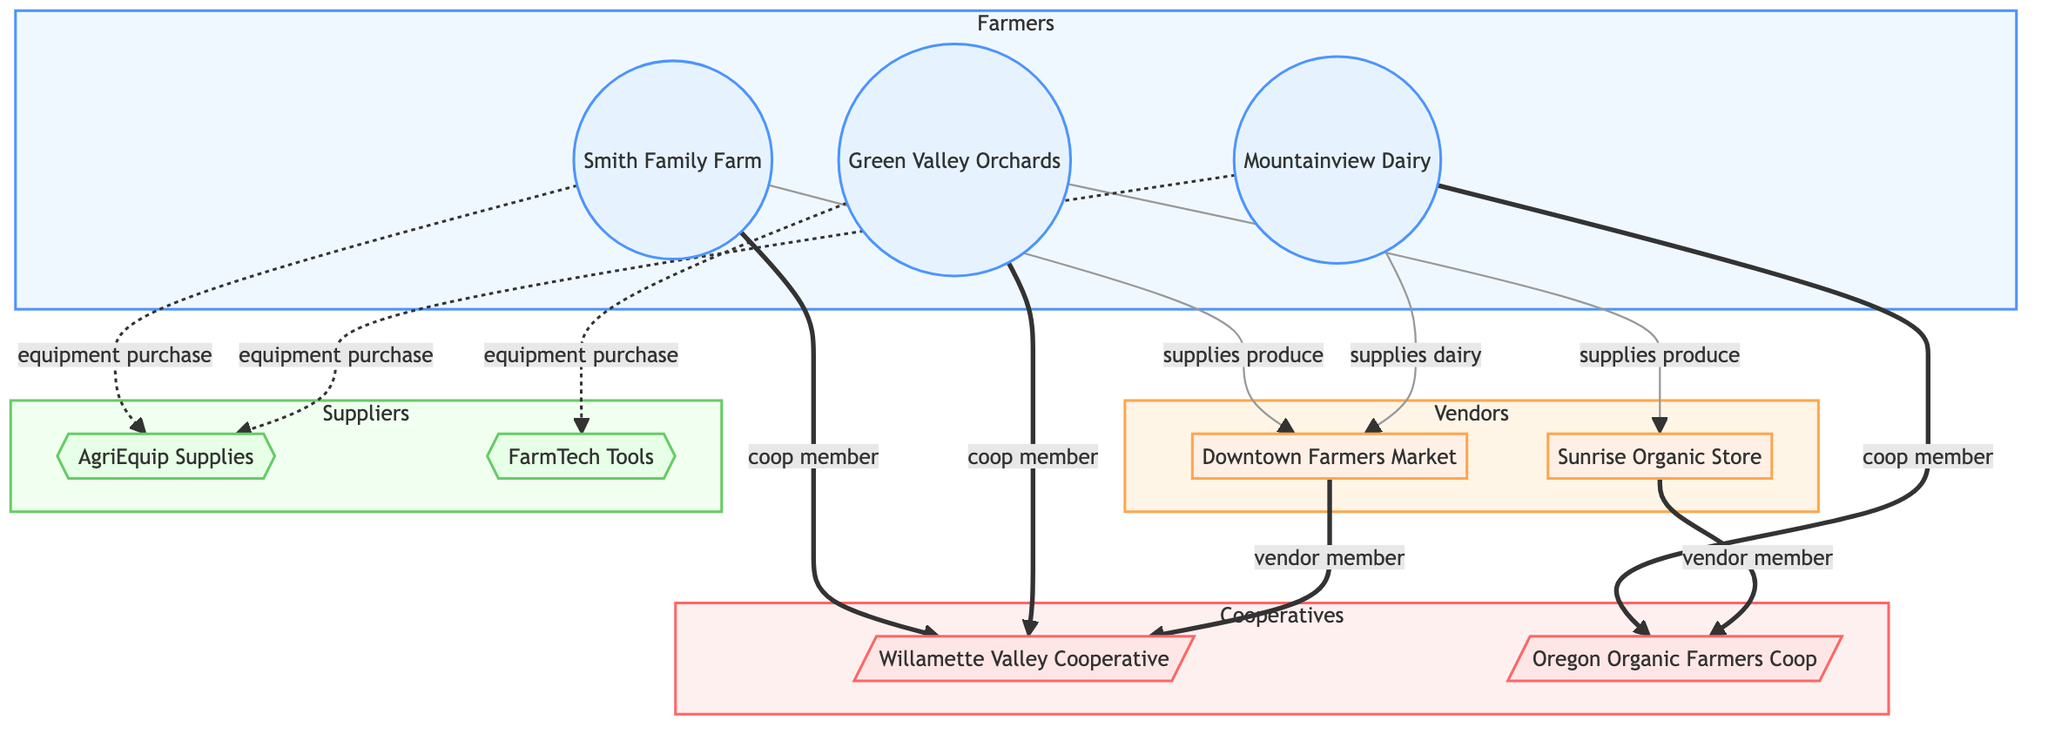What is the total number of farmers in the diagram? There are three nodes labeled as farmers: Smith Family Farm, Green Valley Orchards, and Mountainview Dairy.
Answer: 3 Which vendor does Mountainview Dairy supply dairy to? The edge from Mountainview Dairy points to Downtown Farmers Market with the label "supplies dairy."
Answer: Downtown Farmers Market How many cooperatives are represented in the network? There are two nodes labeled as cooperatives: Willamette Valley Cooperative and Oregon Organic Farmers Coop.
Answer: 2 Which supplier does Smith Family Farm purchase equipment from? Smith Family Farm has a dashed line (equipment purchase) towards AgriEquip Supplies, indicating that it purchases equipment from this supplier.
Answer: AgriEquip Supplies Which cooperative do Green Valley Orchards and Smith Family Farm both belong to? The edges from both Green Valley Orchards and Smith Family Farm lead to the Willamette Valley Cooperative, indicating they are both members of this cooperative.
Answer: Willamette Valley Cooperative Who are the vendor members associated with the Willamette Valley Cooperative? The edge from Downtown Farmers Market shows it is a member of the Willamette Valley Cooperative, indicating it is the vendor associated with that cooperative.
Answer: Downtown Farmers Market Which farmer is associated with the Oregon Organic Farmers Coop? The edge from Mountainview Dairy points to Oregon Organic Farmers Coop with the label "coop member," indicating this farmer's membership.
Answer: Mountainview Dairy How many total edges are there connecting farmers to cooperatives? The edges include Smith Family Farm to Willamette Valley Cooperative, Green Valley Orchards to Willamette Valley Cooperative, and Mountainview Dairy to Oregon Organic Farmers Coop, totaling three edges.
Answer: 3 What type of relationship exists between Green Valley Orchards and Sunrise Organic Store? The relationship is indicated by the edge labeled "supplies produce," showing a direct connection where the farmer supplies produce to the vendor.
Answer: supplies produce 